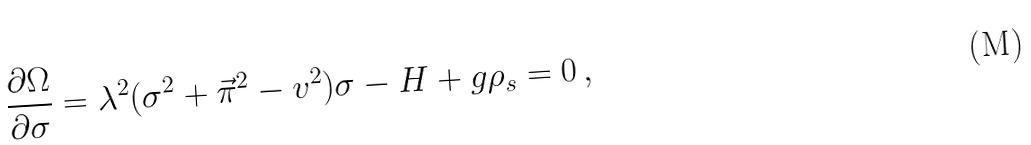Convert formula to latex. <formula><loc_0><loc_0><loc_500><loc_500>\frac { \partial \Omega } { \partial \sigma } = \lambda ^ { 2 } ( \sigma ^ { 2 } + \vec { \pi } ^ { 2 } - v ^ { 2 } ) \sigma - H + g \rho _ { s } = 0 \, ,</formula> 